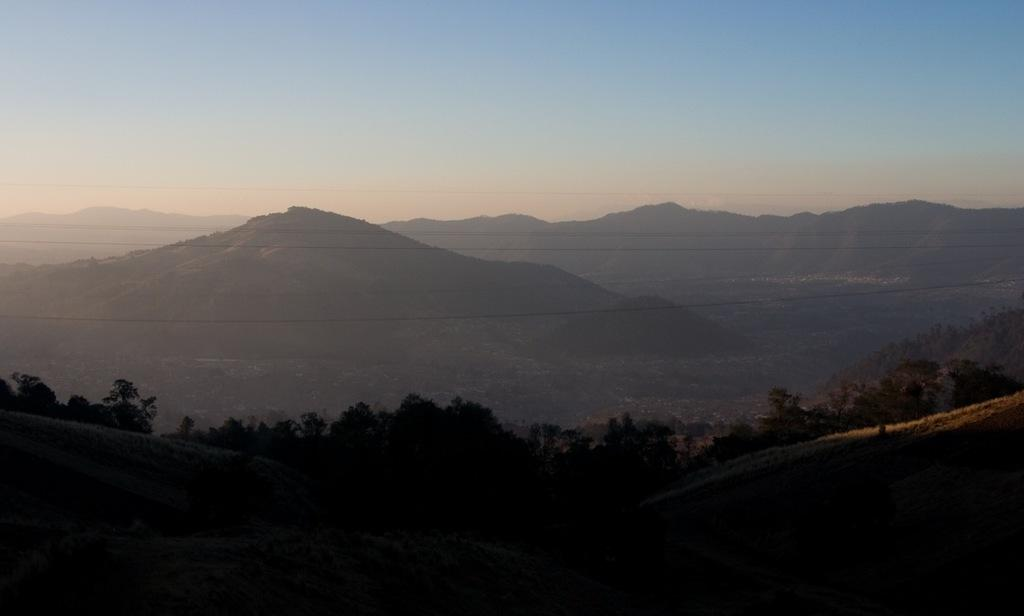What type of vegetation can be seen in the image? There are trees in the image. What can be seen in the distance in the image? There are hills visible in the background of the image. What is visible above the trees and hills in the image? The sky is visible in the background of the image. What type of brass instrument is being played by the lumberjack in the image? There is no lumberjack or brass instrument present in the image. Is there a jail visible in the image? There is no jail present in the image. 